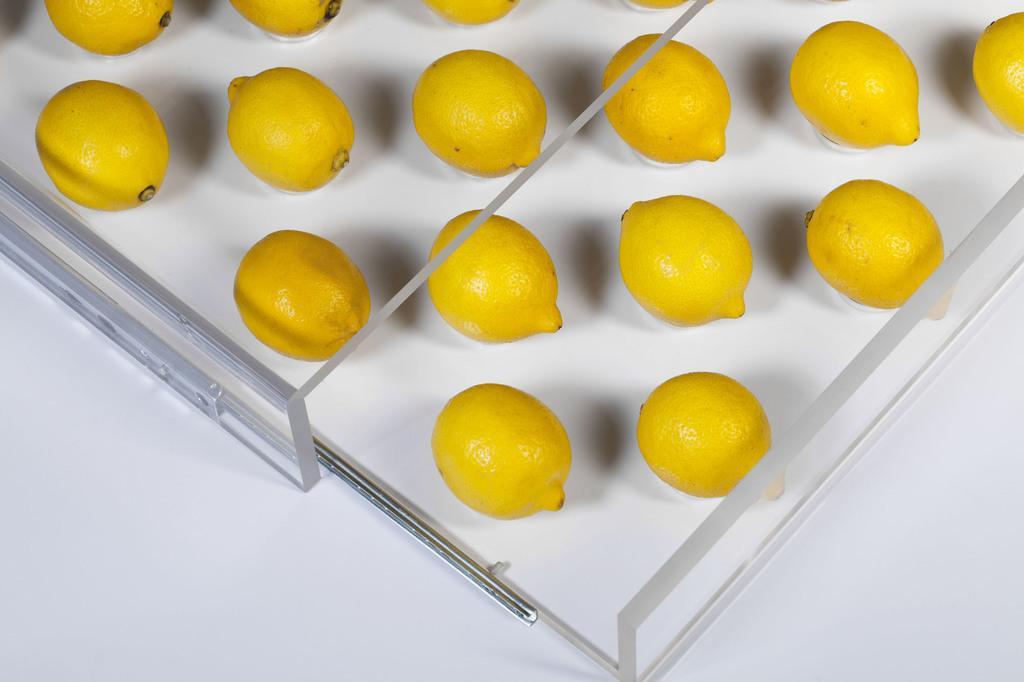Describe this image in one or two sentences. In this picture we can see few lemons. 